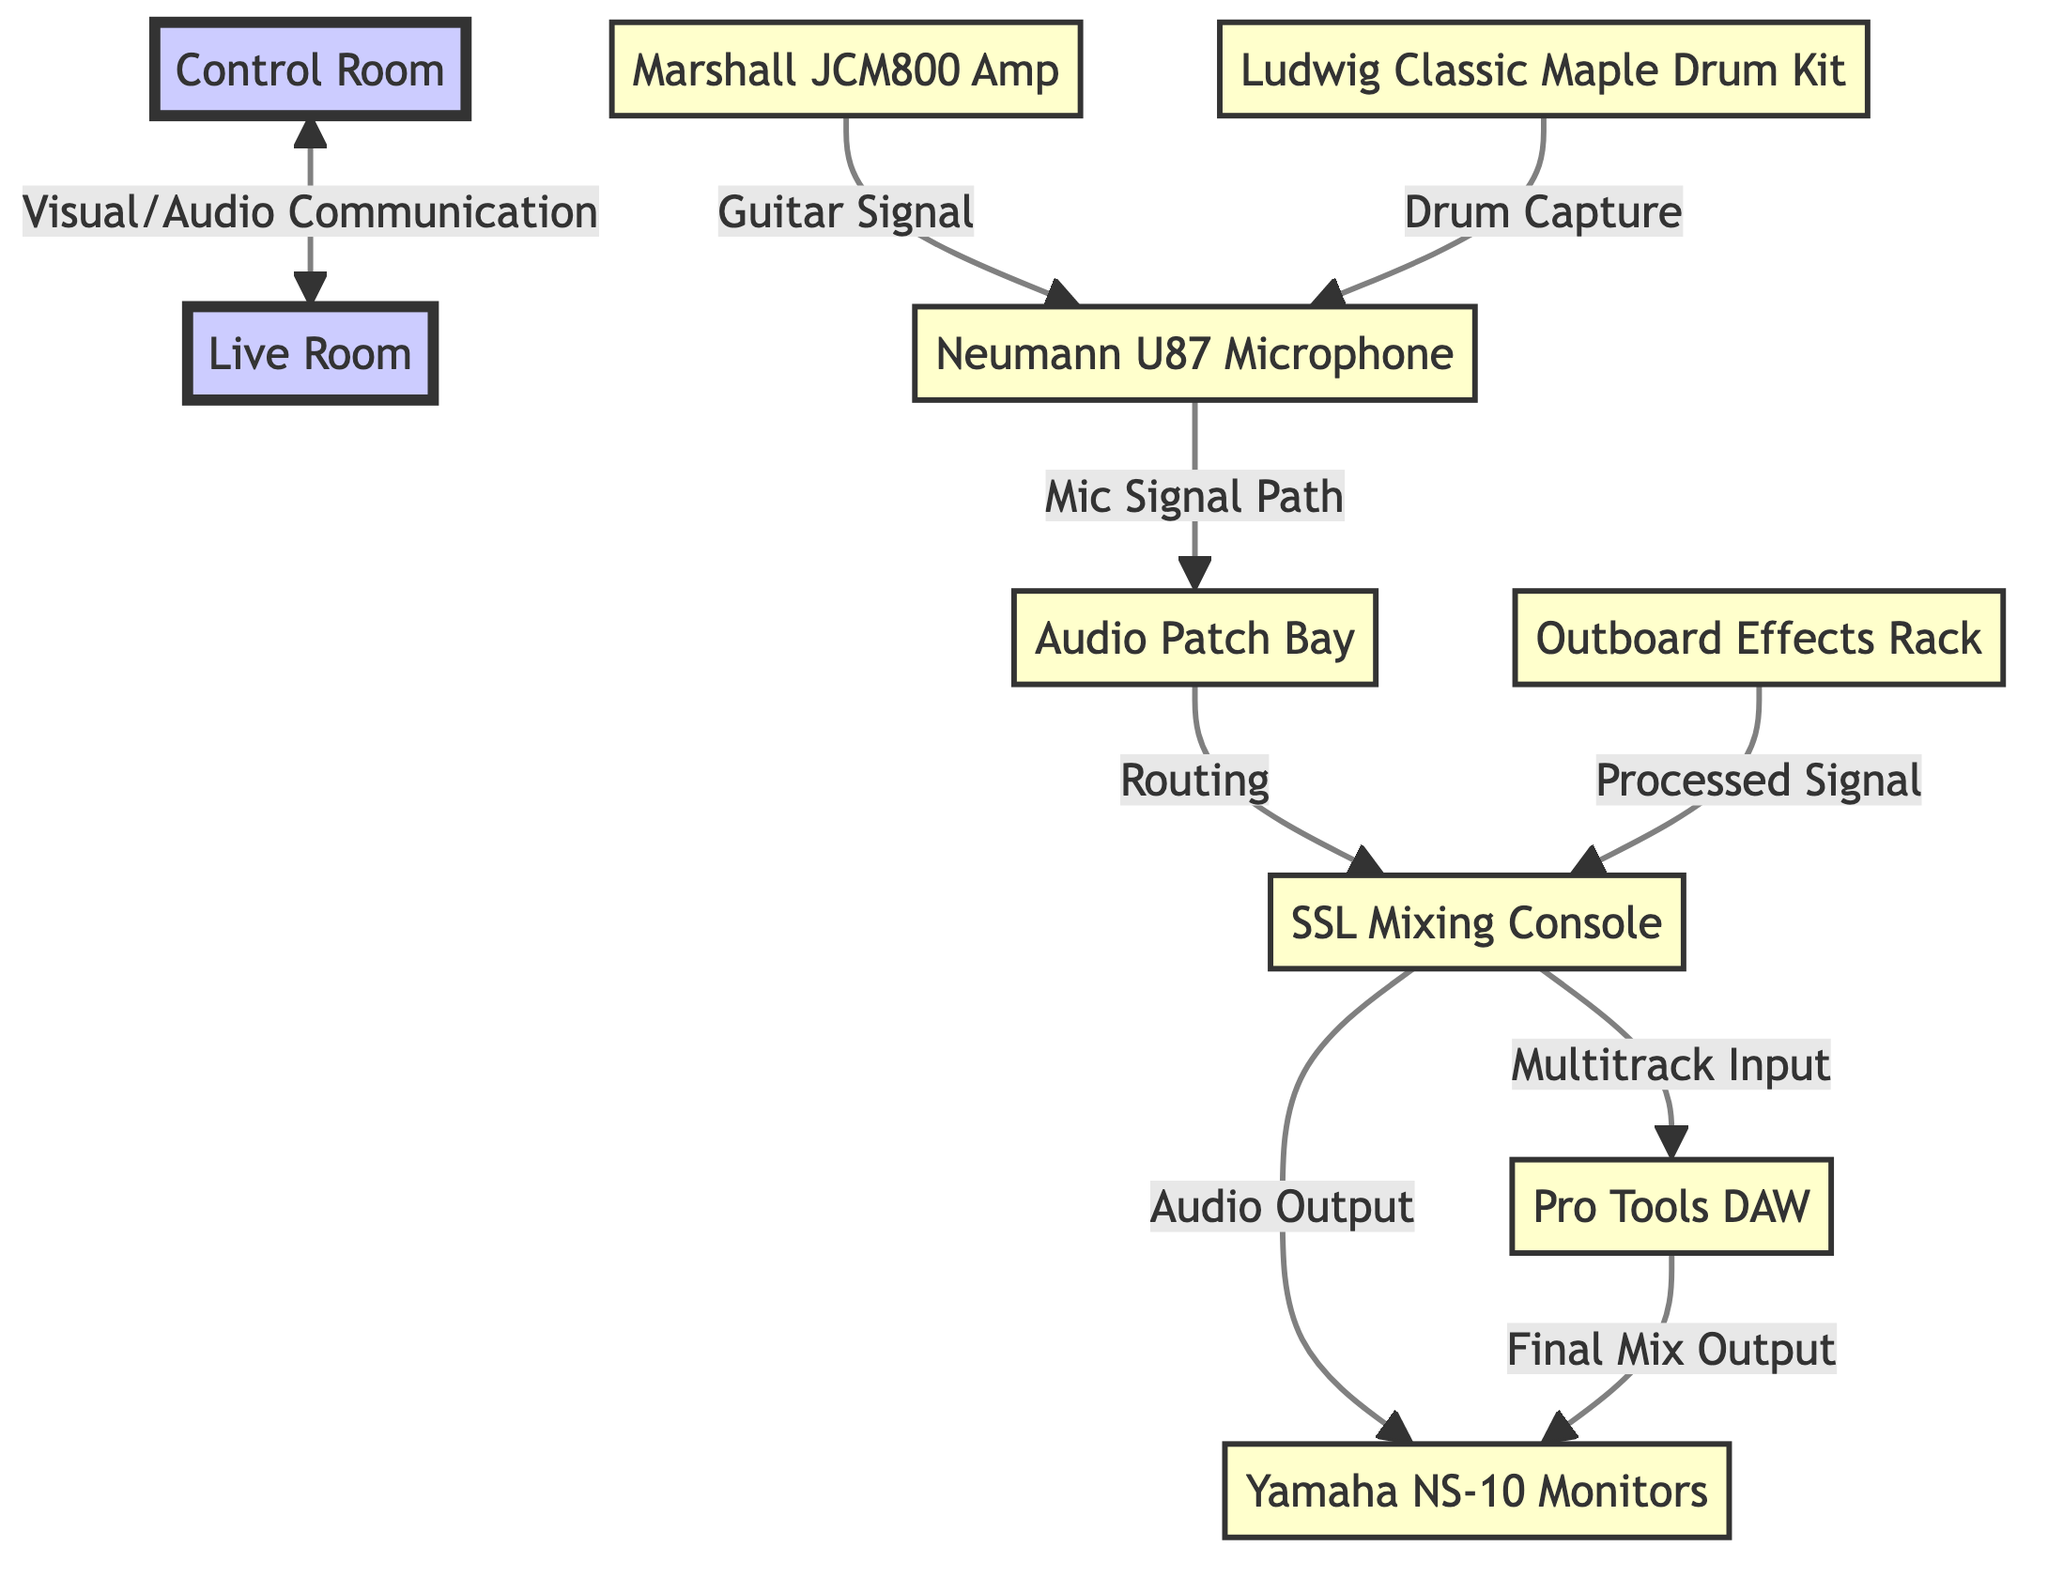What is the main function of the control room? The control room serves as a hub for visual and audio communication with the live room, managing the recording process.
Answer: Visual/Audio Communication How many pieces of equipment are directly connected to the mixing console? There are four pieces of equipment connected to the mixing console: the monitor speakers, the patch bay, the effects rack, and the DAW.
Answer: Four What type of microphone is used in the setup? The diagram indicates that a Neumann U87 microphone is used for capturing audio signals.
Answer: Neumann U87 Microphone What captures the drum sounds in the setup? The Ludwig Classic Maple Drum Kit captures the drum sounds, as indicated in the diagram with a connection to the microphone.
Answer: Ludwig Classic Maple Drum Kit How does the signal flow from the guitar amp to the final mix output? The guitar signal from the Marshall JCM800 amp goes to the Neumann U87 microphone, which then connects to the patch bay, routing to the mixing console, and finally to the Pro Tools DAW for output through the Yamaha NS-10 monitors.
Answer: Marshall JCM800 Amp to Neumann U87 to Patch Bay to Mixing Console to Pro Tools DAW to Yamaha NS-10 Monitors 